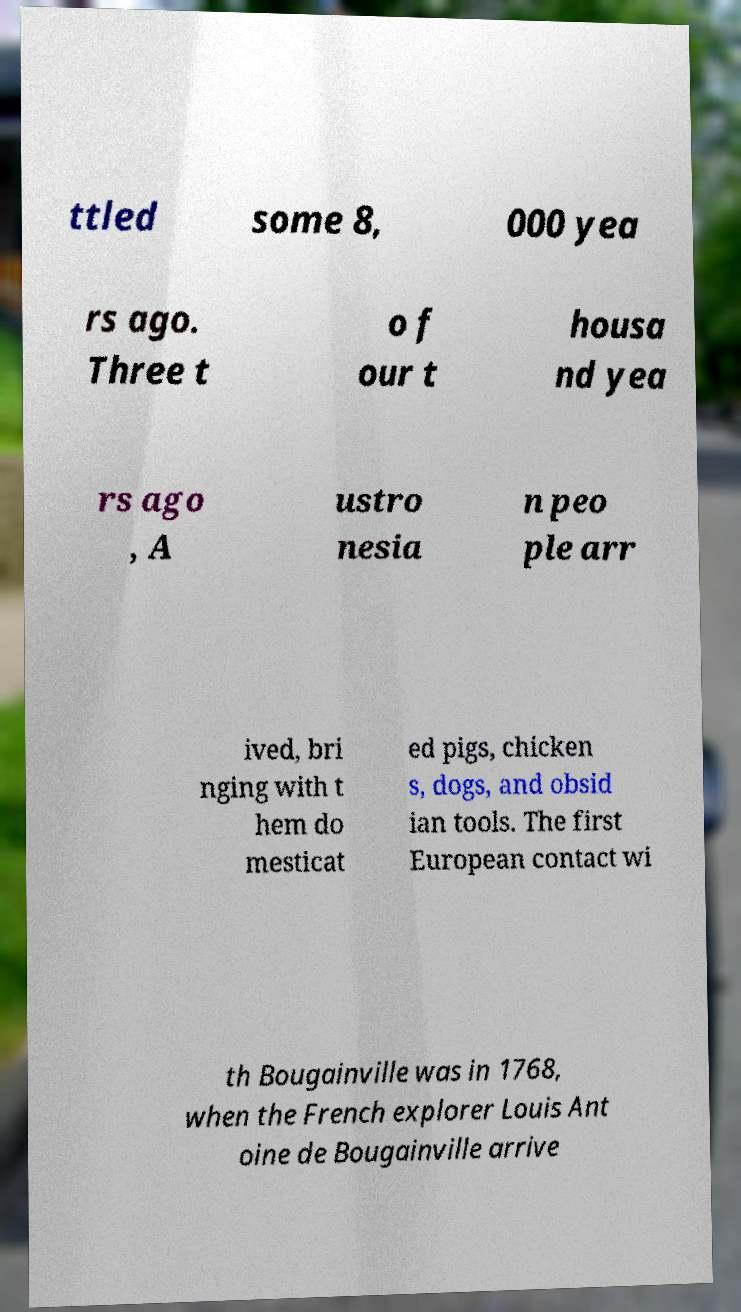Can you read and provide the text displayed in the image?This photo seems to have some interesting text. Can you extract and type it out for me? ttled some 8, 000 yea rs ago. Three t o f our t housa nd yea rs ago , A ustro nesia n peo ple arr ived, bri nging with t hem do mesticat ed pigs, chicken s, dogs, and obsid ian tools. The first European contact wi th Bougainville was in 1768, when the French explorer Louis Ant oine de Bougainville arrive 